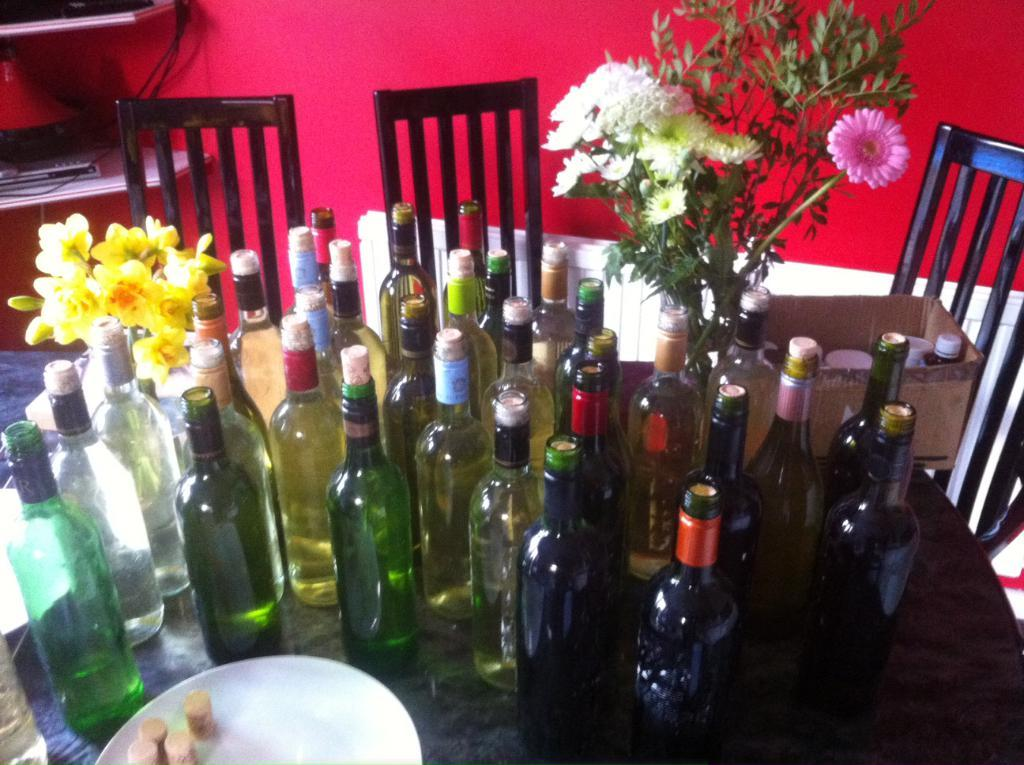What type of beverage containers are present in the image? There are wine bottles in the image. What type of vegetation can be seen in the image? There is a plant and flowers in the image. What is on the table in the image? There is a plate on a table in the image. How many chairs are visible in the image? There are three chairs in the image. What type of collar is visible on the plant in the image? There is no collar present on the plant in the image; it is a plant with flowers. 